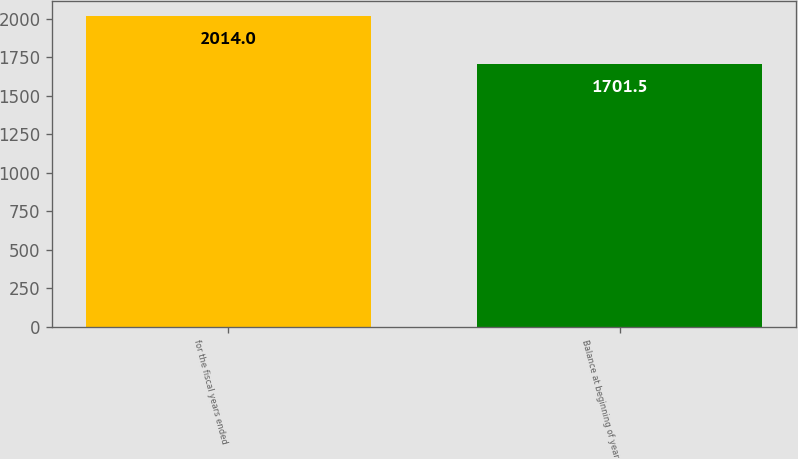Convert chart. <chart><loc_0><loc_0><loc_500><loc_500><bar_chart><fcel>for the fiscal years ended<fcel>Balance at beginning of year<nl><fcel>2014<fcel>1701.5<nl></chart> 